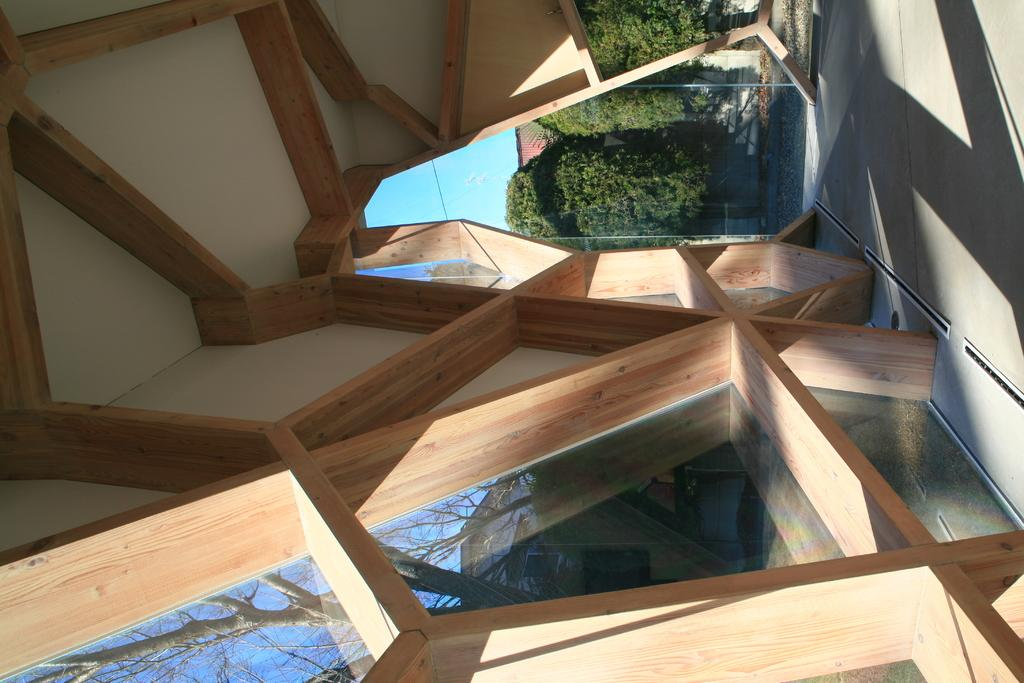Where was the image taken? The image was clicked outside. What structure can be seen in the image? There are wooden sticks built like a wall in the image. What can be seen in the background of the image? There are many trees in the background of the image. What is the surface on which the wooden sticks are placed? There is a floor at the bottom of the image. What type of cactus can be seen in the image? There is no cactus present in the image. What kind of noise can be heard in the image? The image is a still photograph, so no noise can be heard. 